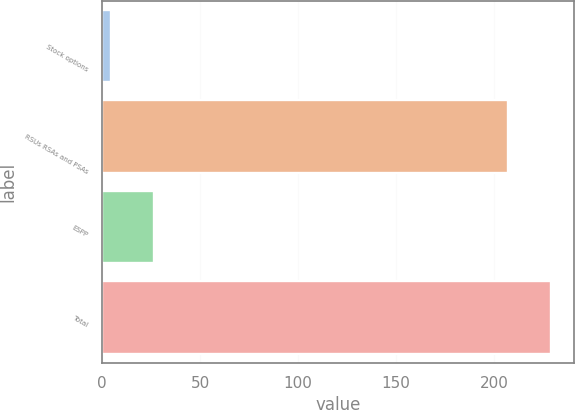Convert chart to OTSL. <chart><loc_0><loc_0><loc_500><loc_500><bar_chart><fcel>Stock options<fcel>RSUs RSAs and PSAs<fcel>ESPP<fcel>Total<nl><fcel>4.4<fcel>206.9<fcel>26.64<fcel>229.14<nl></chart> 